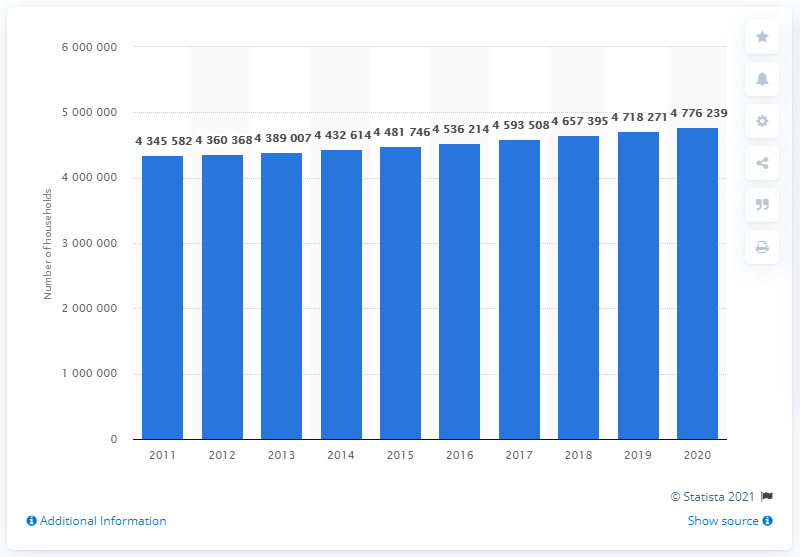Mention a couple of crucial points in this snapshot. In 2020, there were 4,776,239 households in Sweden. 